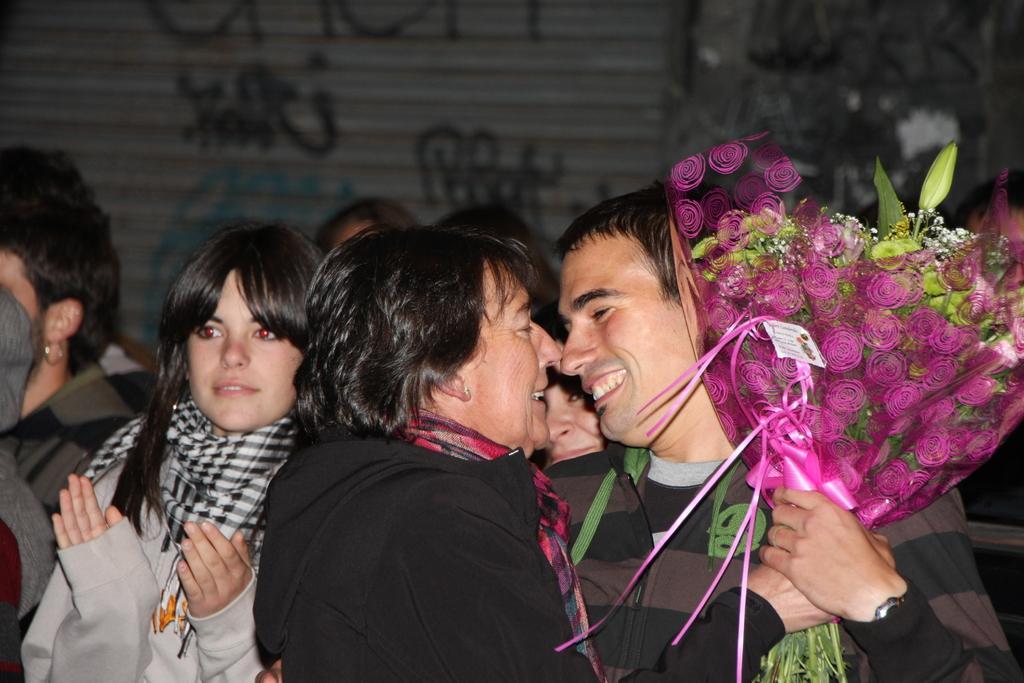Describe this image in one or two sentences. In the foreground of this picture, there is a man and a woman holding a bouquet in their hand. In the background, there are persons standing and a shatter. 